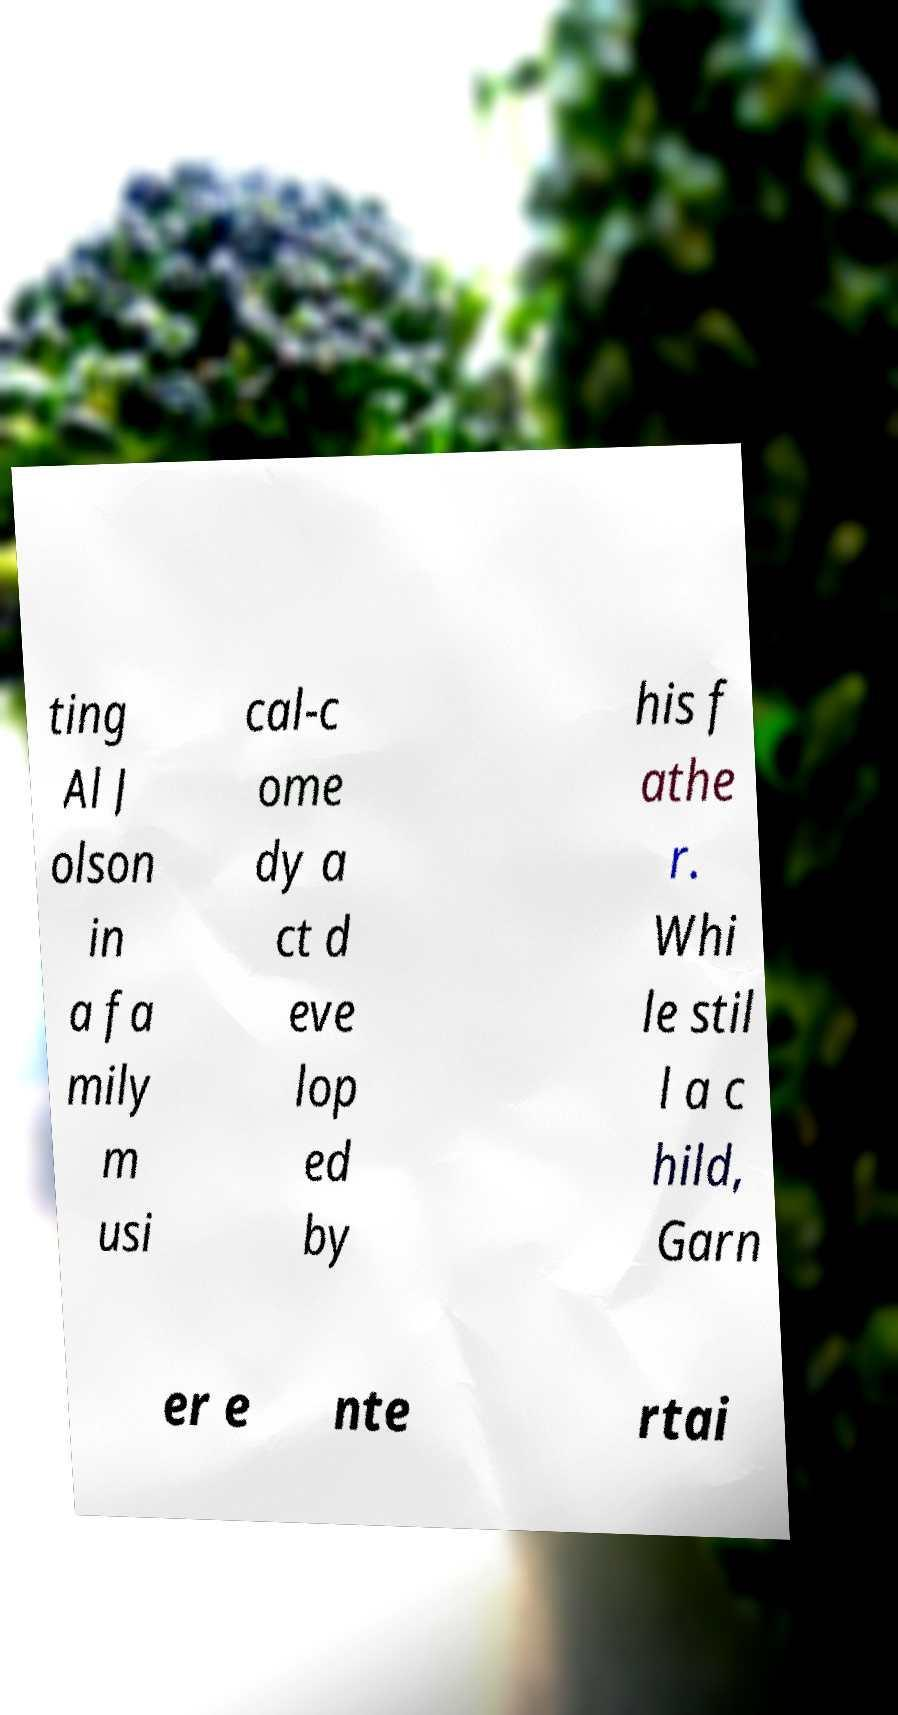Could you extract and type out the text from this image? ting Al J olson in a fa mily m usi cal-c ome dy a ct d eve lop ed by his f athe r. Whi le stil l a c hild, Garn er e nte rtai 